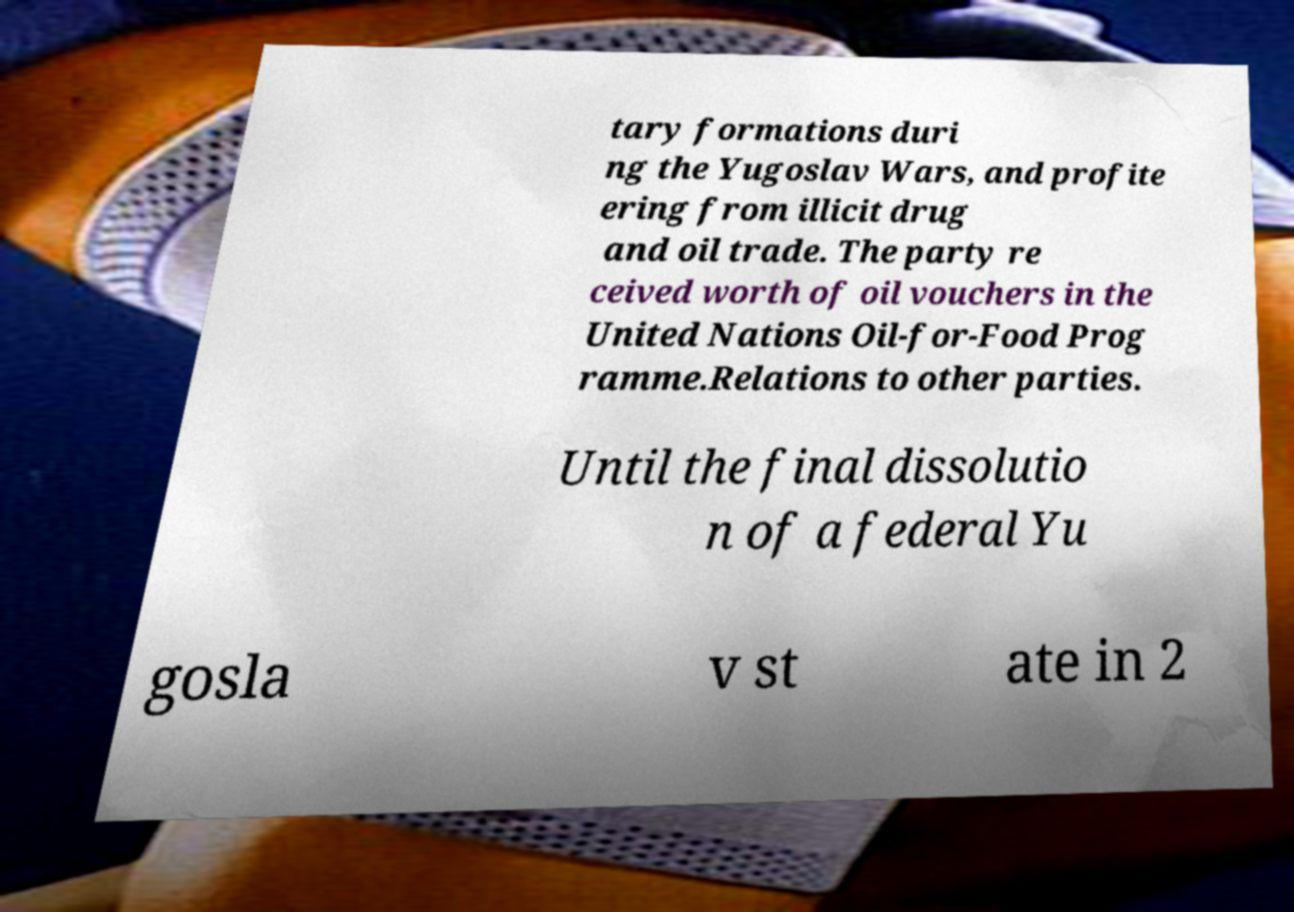Please identify and transcribe the text found in this image. tary formations duri ng the Yugoslav Wars, and profite ering from illicit drug and oil trade. The party re ceived worth of oil vouchers in the United Nations Oil-for-Food Prog ramme.Relations to other parties. Until the final dissolutio n of a federal Yu gosla v st ate in 2 